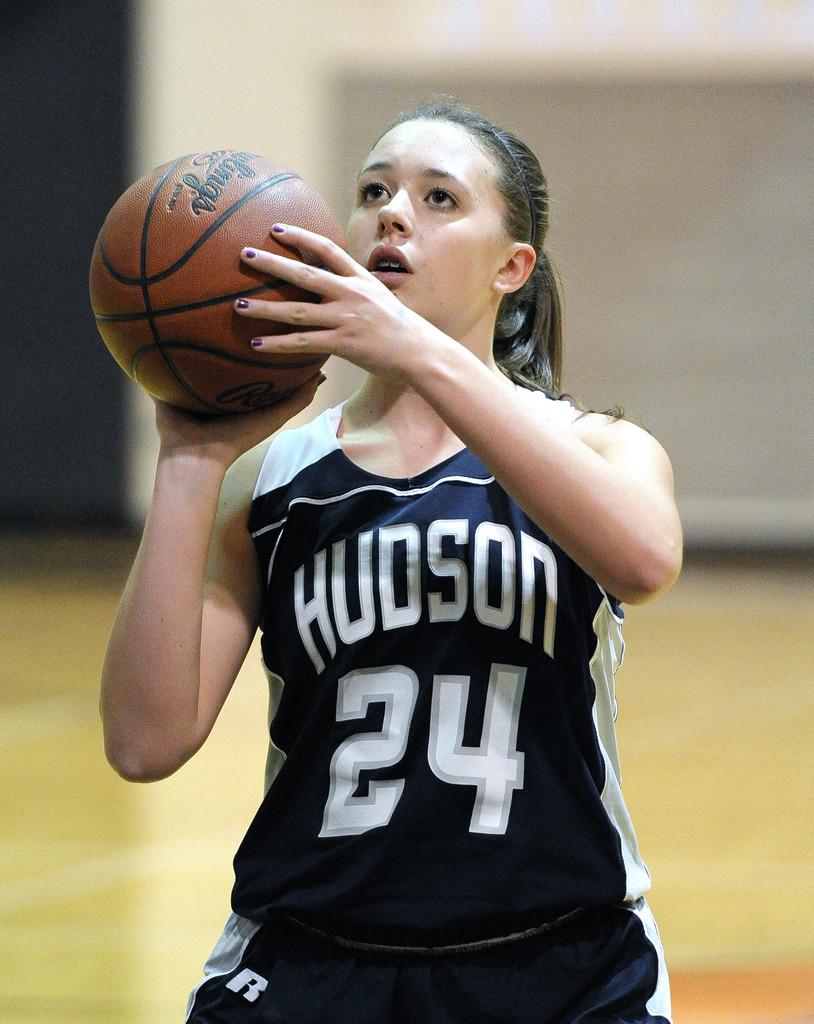What team does player 24 play for?
Offer a very short reply. Hudson. What letter is on this player's shorts?
Your response must be concise. R. 